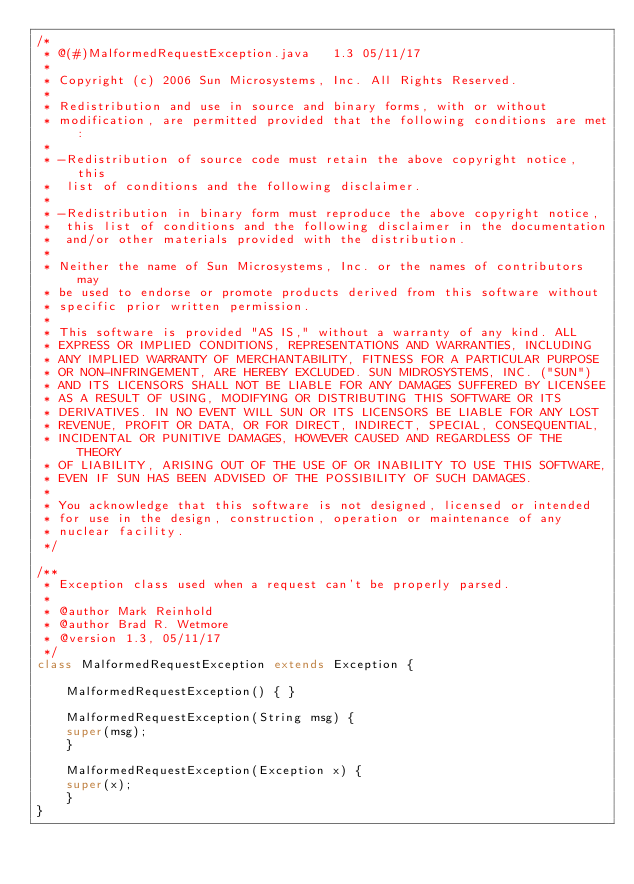<code> <loc_0><loc_0><loc_500><loc_500><_Java_>/*
 * @(#)MalformedRequestException.java	1.3 05/11/17
 * 
 * Copyright (c) 2006 Sun Microsystems, Inc. All Rights Reserved.
 * 
 * Redistribution and use in source and binary forms, with or without
 * modification, are permitted provided that the following conditions are met:
 * 
 * -Redistribution of source code must retain the above copyright notice, this
 *  list of conditions and the following disclaimer.
 * 
 * -Redistribution in binary form must reproduce the above copyright notice, 
 *  this list of conditions and the following disclaimer in the documentation
 *  and/or other materials provided with the distribution.
 * 
 * Neither the name of Sun Microsystems, Inc. or the names of contributors may 
 * be used to endorse or promote products derived from this software without 
 * specific prior written permission.
 * 
 * This software is provided "AS IS," without a warranty of any kind. ALL 
 * EXPRESS OR IMPLIED CONDITIONS, REPRESENTATIONS AND WARRANTIES, INCLUDING
 * ANY IMPLIED WARRANTY OF MERCHANTABILITY, FITNESS FOR A PARTICULAR PURPOSE
 * OR NON-INFRINGEMENT, ARE HEREBY EXCLUDED. SUN MIDROSYSTEMS, INC. ("SUN")
 * AND ITS LICENSORS SHALL NOT BE LIABLE FOR ANY DAMAGES SUFFERED BY LICENSEE
 * AS A RESULT OF USING, MODIFYING OR DISTRIBUTING THIS SOFTWARE OR ITS
 * DERIVATIVES. IN NO EVENT WILL SUN OR ITS LICENSORS BE LIABLE FOR ANY LOST 
 * REVENUE, PROFIT OR DATA, OR FOR DIRECT, INDIRECT, SPECIAL, CONSEQUENTIAL, 
 * INCIDENTAL OR PUNITIVE DAMAGES, HOWEVER CAUSED AND REGARDLESS OF THE THEORY 
 * OF LIABILITY, ARISING OUT OF THE USE OF OR INABILITY TO USE THIS SOFTWARE, 
 * EVEN IF SUN HAS BEEN ADVISED OF THE POSSIBILITY OF SUCH DAMAGES.
 * 
 * You acknowledge that this software is not designed, licensed or intended
 * for use in the design, construction, operation or maintenance of any
 * nuclear facility.
 */

/**
 * Exception class used when a request can't be properly parsed.
 *
 * @author Mark Reinhold
 * @author Brad R. Wetmore
 * @version 1.3, 05/11/17
 */
class MalformedRequestException extends Exception {

    MalformedRequestException() { }

    MalformedRequestException(String msg) {
	super(msg);
    }

    MalformedRequestException(Exception x) {
	super(x);
    }
}
</code> 